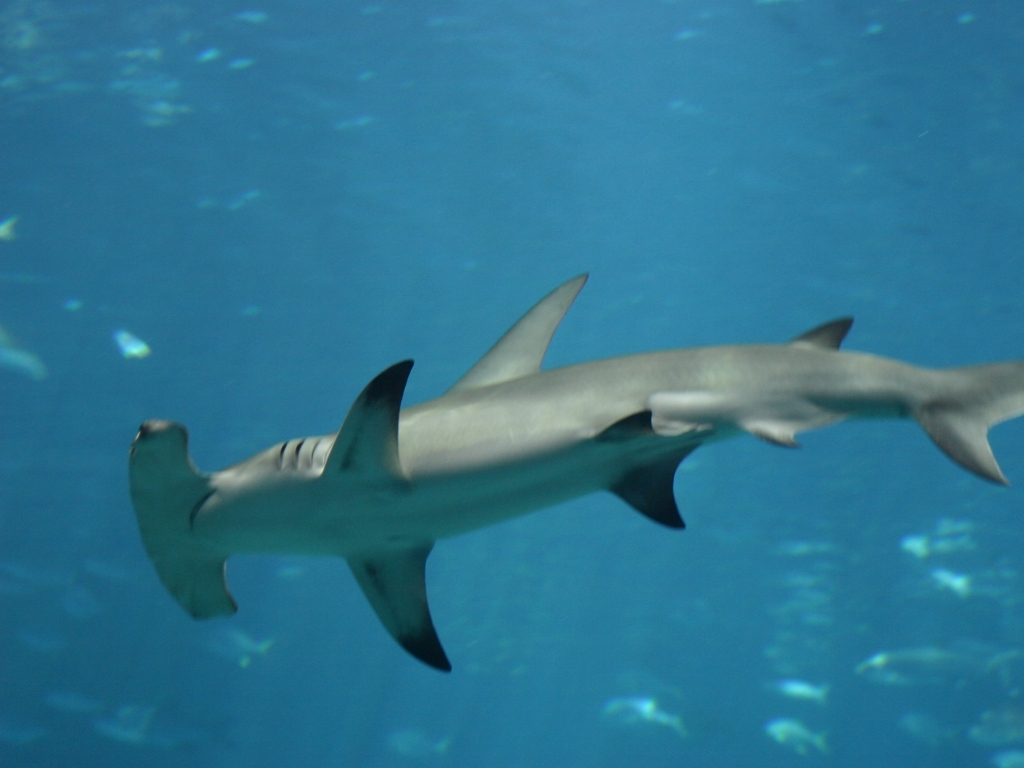Can you provide more information about the creature shown in the image? The image features a hammerhead shark, easily recognizable by its unique hammer or T-shaped head, known as the cephalofoil. Hammerheads are found in warmer waters along coastlines and continental shelves. The structure of their head provides improved navigation and sensory perception to hunt prey like fish, squid, and crustaceans. They're fascinating creatures of the ocean! 